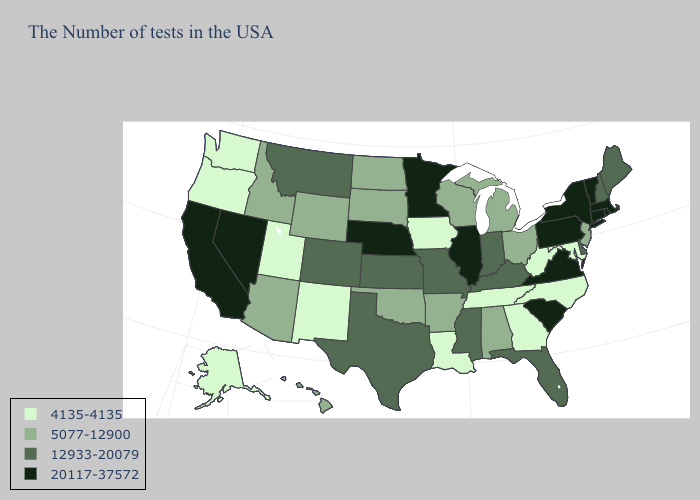What is the value of Colorado?
Keep it brief. 12933-20079. Name the states that have a value in the range 5077-12900?
Concise answer only. New Jersey, Ohio, Michigan, Alabama, Wisconsin, Arkansas, Oklahoma, South Dakota, North Dakota, Wyoming, Arizona, Idaho, Hawaii. Among the states that border Georgia , which have the lowest value?
Give a very brief answer. North Carolina, Tennessee. Which states have the lowest value in the USA?
Short answer required. Maryland, North Carolina, West Virginia, Georgia, Tennessee, Louisiana, Iowa, New Mexico, Utah, Washington, Oregon, Alaska. Does Iowa have the lowest value in the MidWest?
Keep it brief. Yes. What is the lowest value in the South?
Quick response, please. 4135-4135. What is the value of Nevada?
Be succinct. 20117-37572. Does Alaska have the lowest value in the USA?
Short answer required. Yes. Which states have the lowest value in the USA?
Answer briefly. Maryland, North Carolina, West Virginia, Georgia, Tennessee, Louisiana, Iowa, New Mexico, Utah, Washington, Oregon, Alaska. What is the highest value in states that border Kentucky?
Short answer required. 20117-37572. Does Florida have the lowest value in the USA?
Write a very short answer. No. Name the states that have a value in the range 5077-12900?
Write a very short answer. New Jersey, Ohio, Michigan, Alabama, Wisconsin, Arkansas, Oklahoma, South Dakota, North Dakota, Wyoming, Arizona, Idaho, Hawaii. Does the first symbol in the legend represent the smallest category?
Concise answer only. Yes. Does California have the highest value in the West?
Write a very short answer. Yes. How many symbols are there in the legend?
Be succinct. 4. 